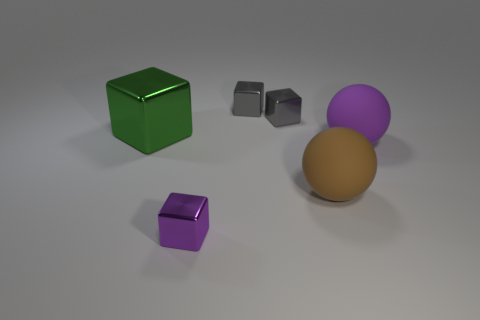What materials do the objects in the image appear to be made of? The objects in the image seem to have different textures indicating various materials. The green and purple cubes have specular and slightly reflective surfaces, suggesting they might be made of plastic or polished metal. The brown sphere appears matte, potentially resembling rubber or a similar non-reflective material. 